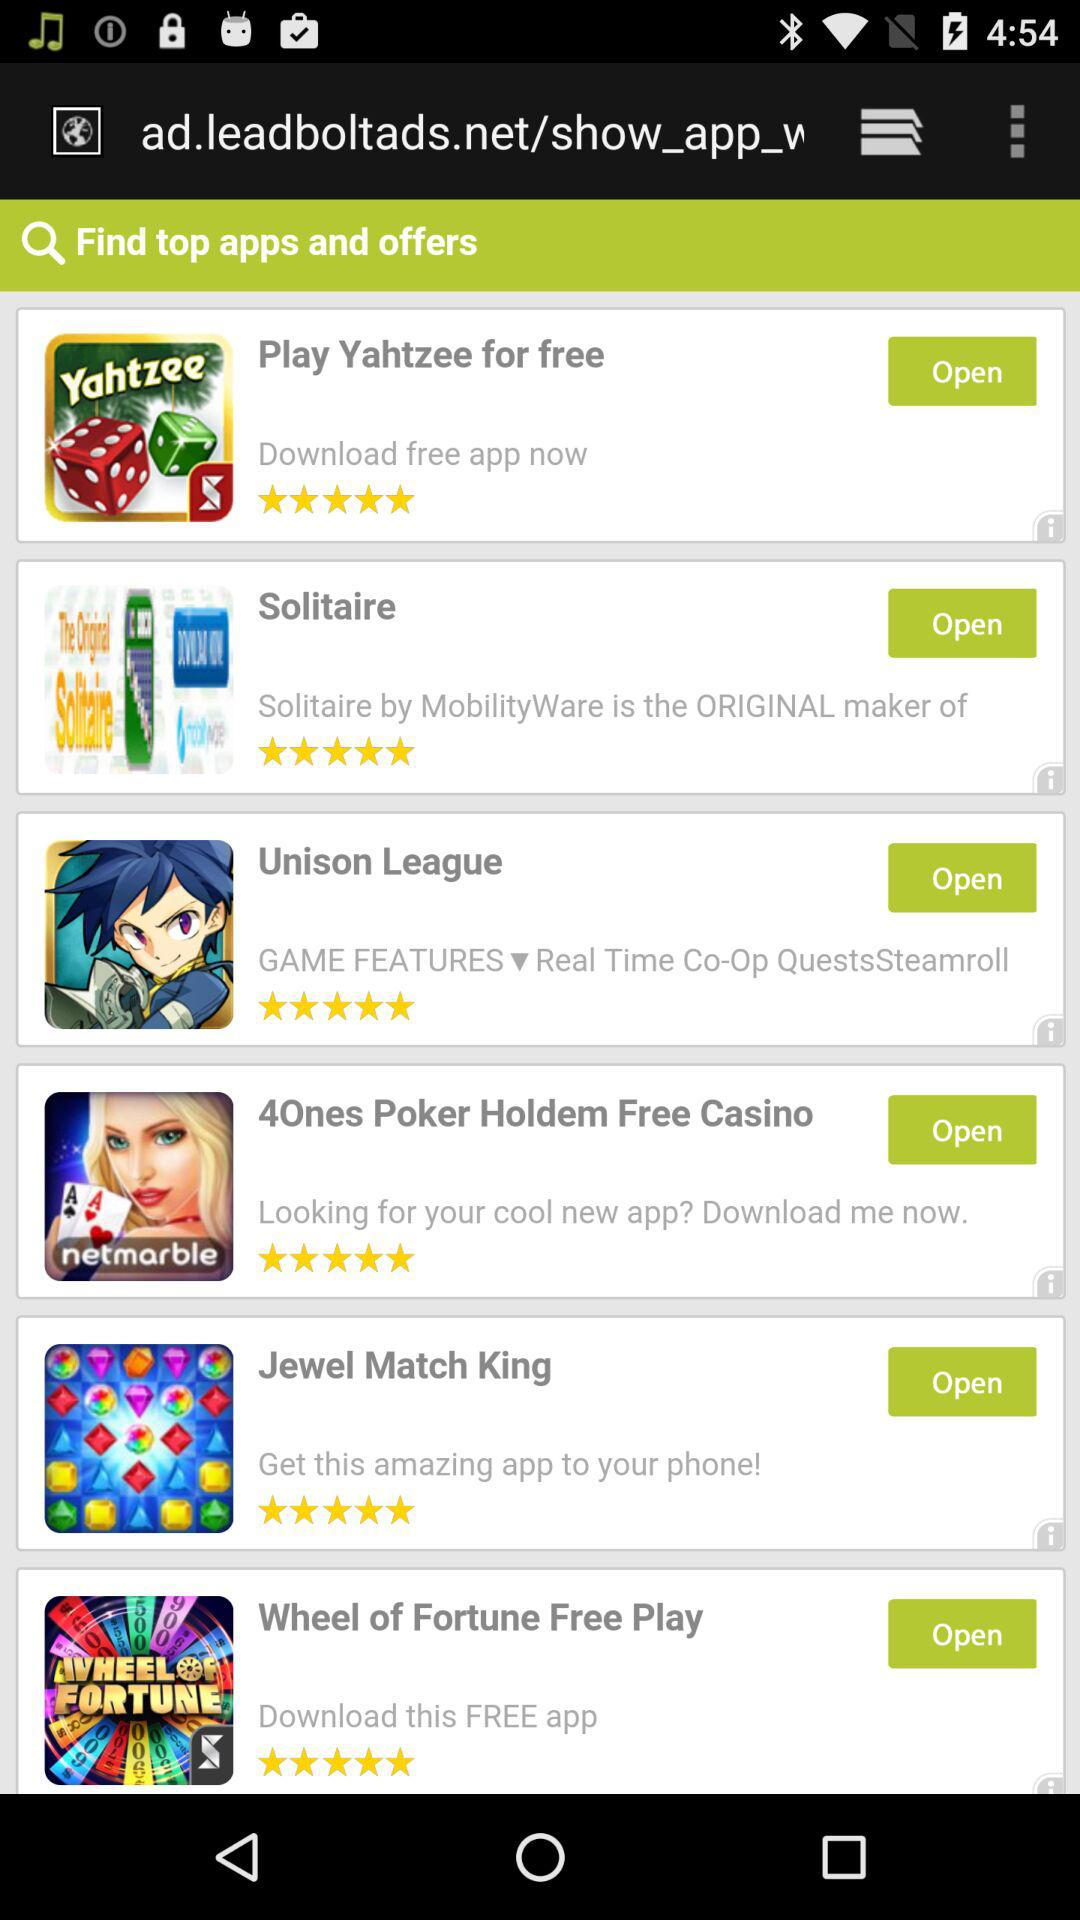How many stars are given to "Solitaire"? There are 5 stars. 